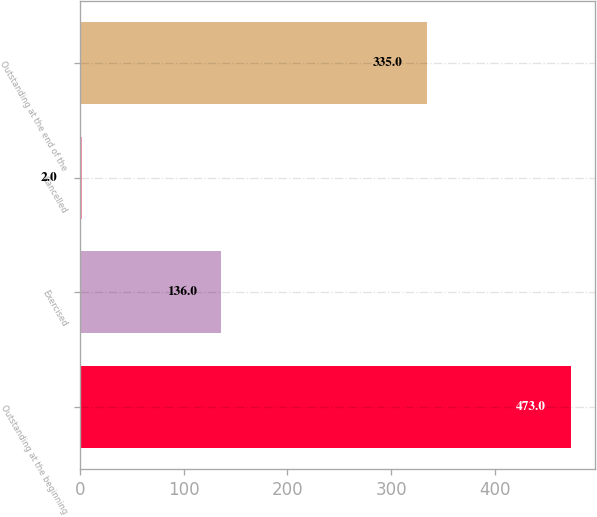<chart> <loc_0><loc_0><loc_500><loc_500><bar_chart><fcel>Outstanding at the beginning<fcel>Exercised<fcel>Cancelled<fcel>Outstanding at the end of the<nl><fcel>473<fcel>136<fcel>2<fcel>335<nl></chart> 